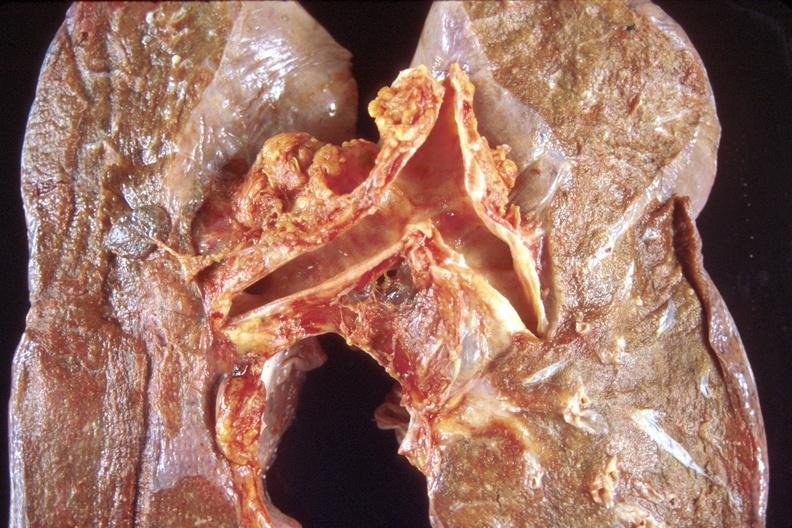s metastatic adenocarcinoma present?
Answer the question using a single word or phrase. No 